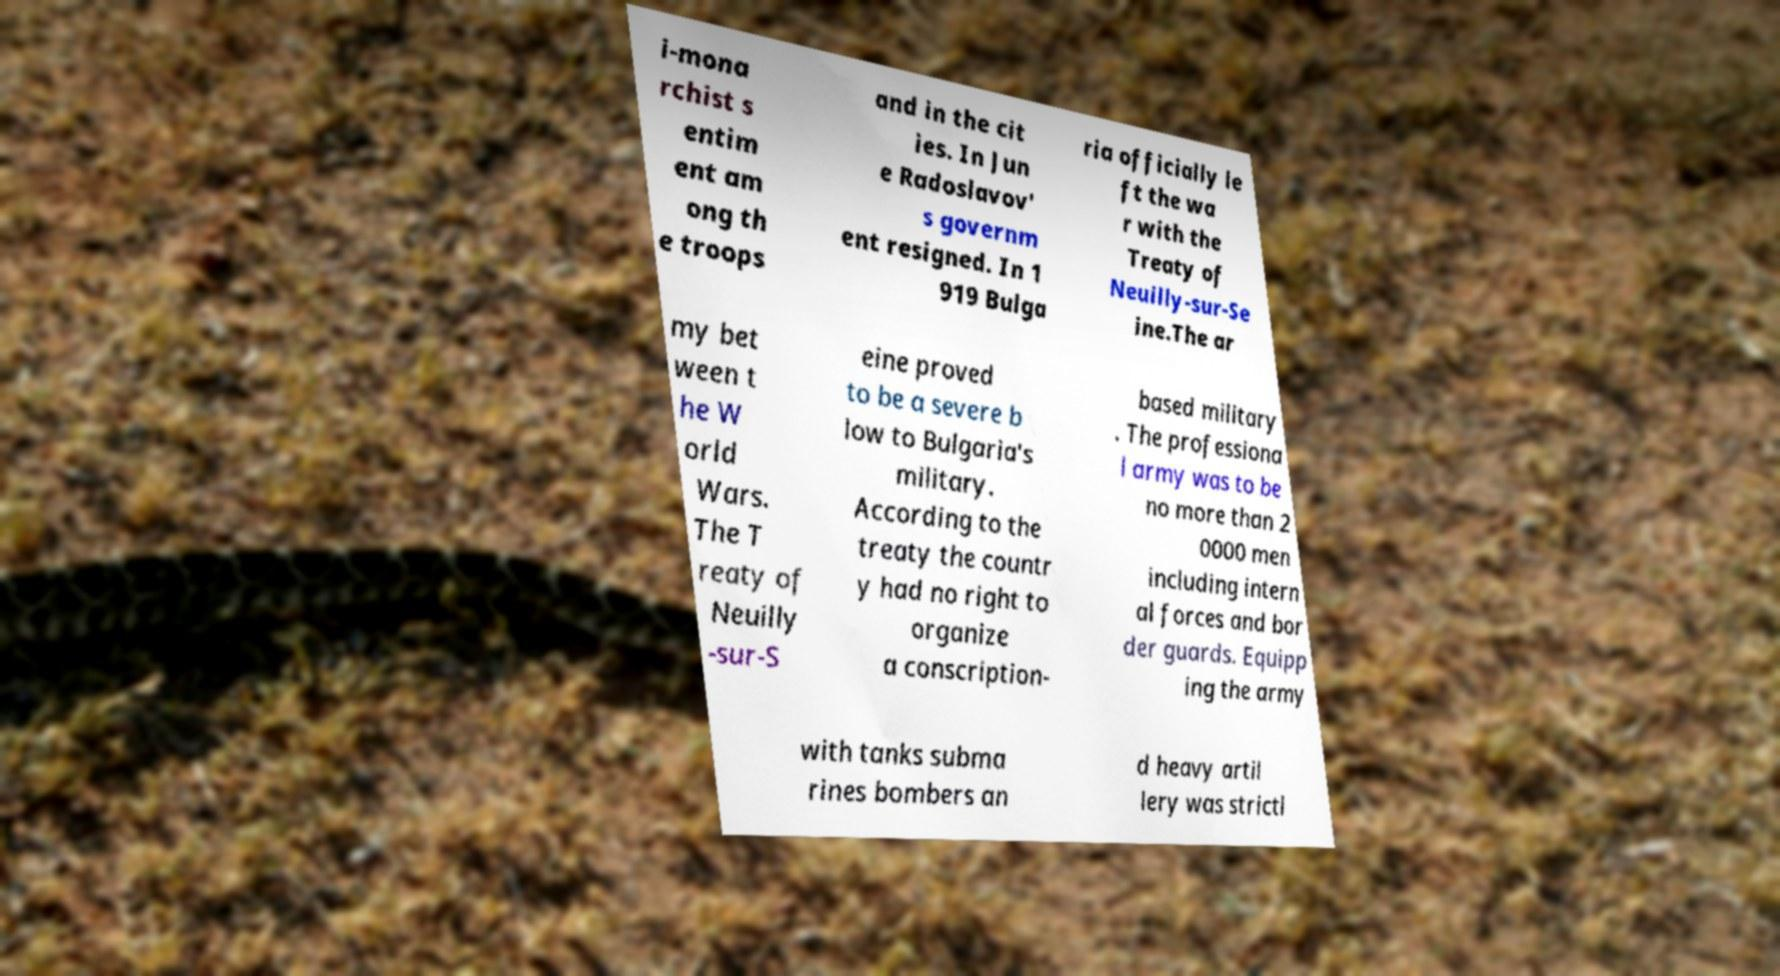Can you read and provide the text displayed in the image?This photo seems to have some interesting text. Can you extract and type it out for me? i-mona rchist s entim ent am ong th e troops and in the cit ies. In Jun e Radoslavov' s governm ent resigned. In 1 919 Bulga ria officially le ft the wa r with the Treaty of Neuilly-sur-Se ine.The ar my bet ween t he W orld Wars. The T reaty of Neuilly -sur-S eine proved to be a severe b low to Bulgaria's military. According to the treaty the countr y had no right to organize a conscription- based military . The professiona l army was to be no more than 2 0000 men including intern al forces and bor der guards. Equipp ing the army with tanks subma rines bombers an d heavy artil lery was strictl 